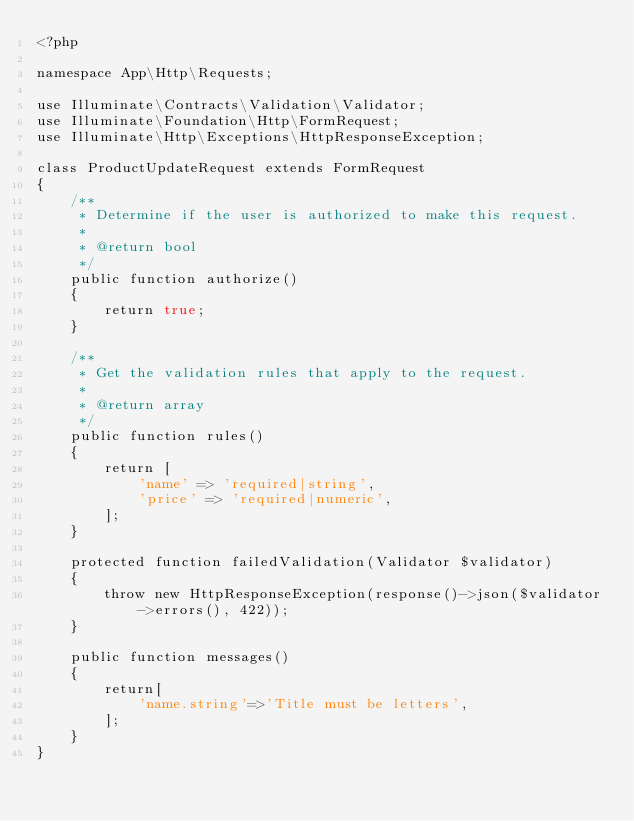<code> <loc_0><loc_0><loc_500><loc_500><_PHP_><?php

namespace App\Http\Requests;

use Illuminate\Contracts\Validation\Validator;
use Illuminate\Foundation\Http\FormRequest;
use Illuminate\Http\Exceptions\HttpResponseException;

class ProductUpdateRequest extends FormRequest
{
    /**
     * Determine if the user is authorized to make this request.
     *
     * @return bool
     */
    public function authorize()
    {
        return true;
    }

    /**
     * Get the validation rules that apply to the request.
     *
     * @return array
     */
    public function rules()
    {
        return [
            'name' => 'required|string',
            'price' => 'required|numeric',
        ];
    }

    protected function failedValidation(Validator $validator)
    {
        throw new HttpResponseException(response()->json($validator->errors(), 422));
    }

    public function messages()
    {
        return[
            'name.string'=>'Title must be letters',
        ];
    }
}
</code> 